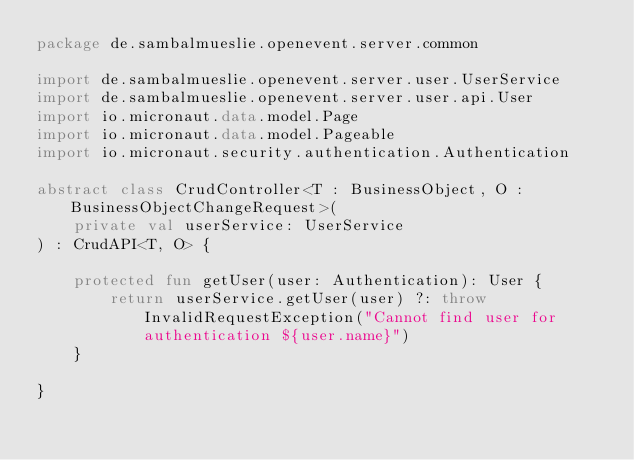Convert code to text. <code><loc_0><loc_0><loc_500><loc_500><_Kotlin_>package de.sambalmueslie.openevent.server.common

import de.sambalmueslie.openevent.server.user.UserService
import de.sambalmueslie.openevent.server.user.api.User
import io.micronaut.data.model.Page
import io.micronaut.data.model.Pageable
import io.micronaut.security.authentication.Authentication

abstract class CrudController<T : BusinessObject, O : BusinessObjectChangeRequest>(
	private val userService: UserService
) : CrudAPI<T, O> {

	protected fun getUser(user: Authentication): User {
		return userService.getUser(user) ?: throw InvalidRequestException("Cannot find user for authentication ${user.name}")
	}

}
</code> 